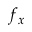Convert formula to latex. <formula><loc_0><loc_0><loc_500><loc_500>f _ { x }</formula> 